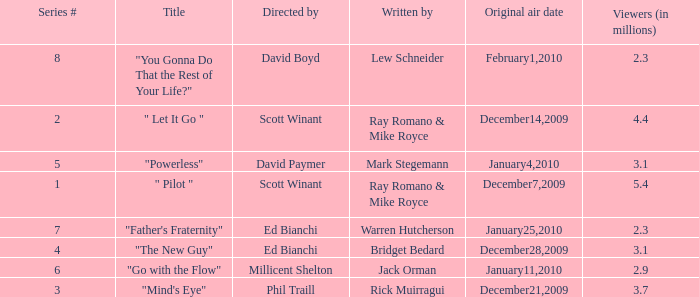What is the original air date of "Powerless"? January4,2010. 